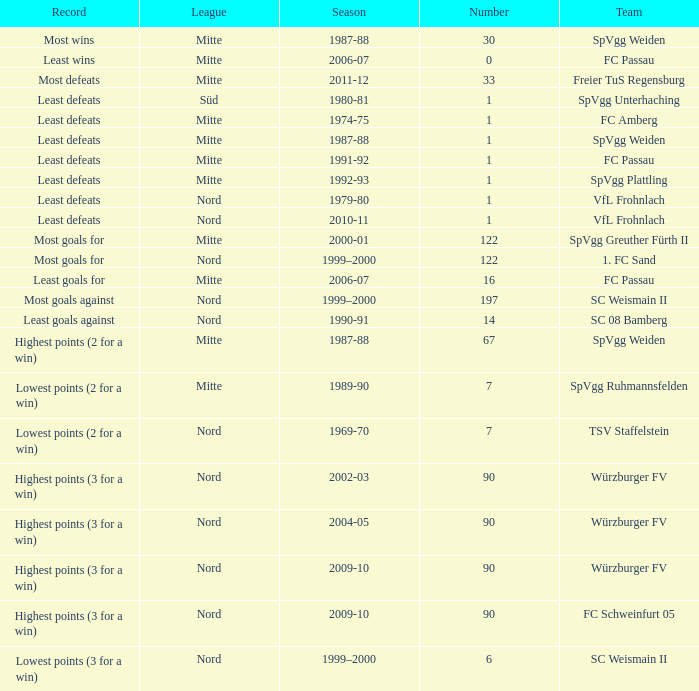What league has a number less than 122, and least wins as the record? Mitte. 